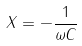Convert formula to latex. <formula><loc_0><loc_0><loc_500><loc_500>X = - \frac { 1 } { \omega C }</formula> 